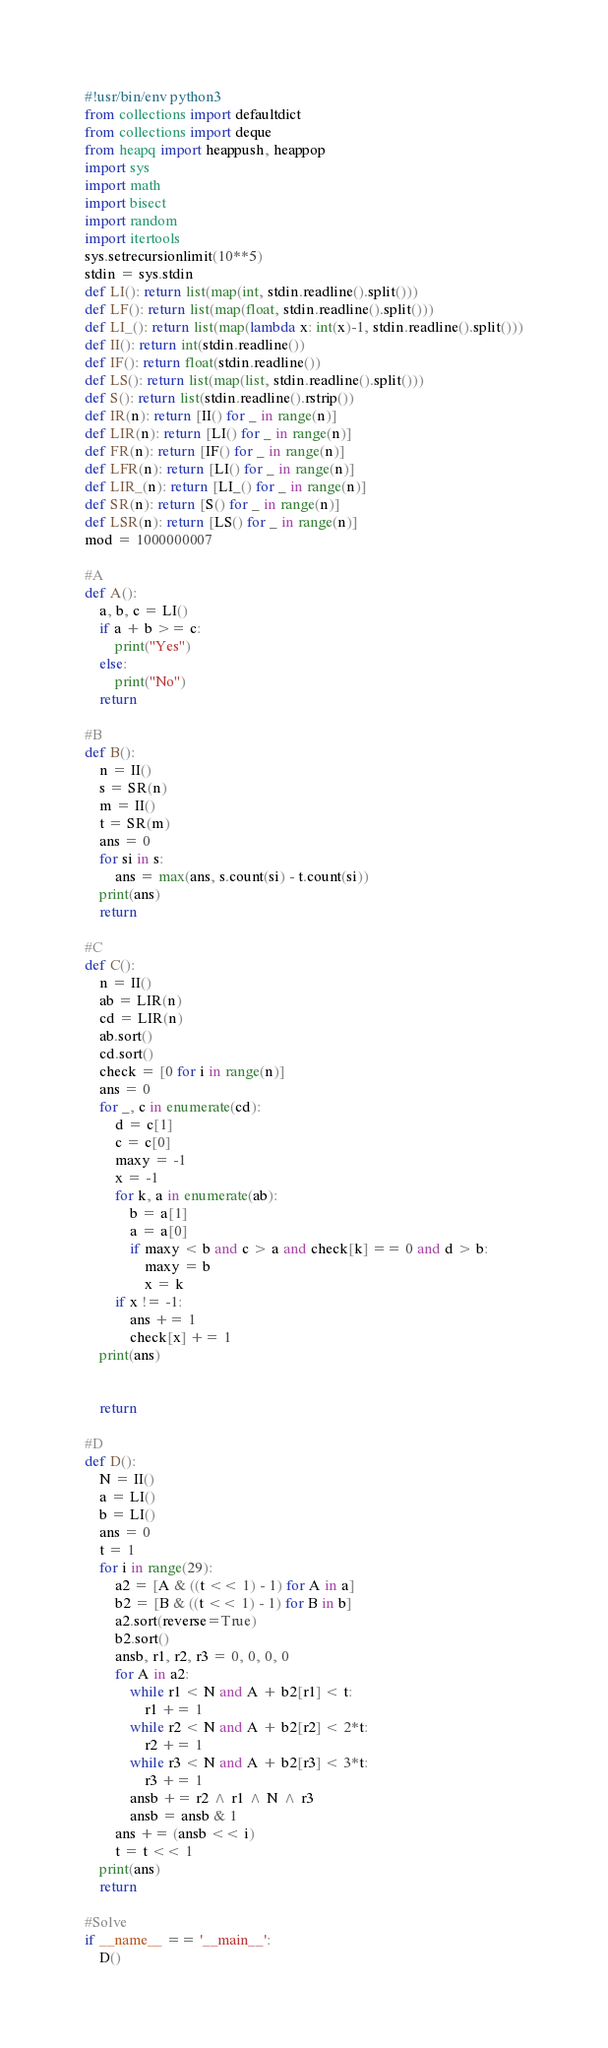<code> <loc_0><loc_0><loc_500><loc_500><_Python_>#!usr/bin/env python3
from collections import defaultdict
from collections import deque
from heapq import heappush, heappop
import sys
import math
import bisect
import random
import itertools
sys.setrecursionlimit(10**5)
stdin = sys.stdin
def LI(): return list(map(int, stdin.readline().split()))
def LF(): return list(map(float, stdin.readline().split()))
def LI_(): return list(map(lambda x: int(x)-1, stdin.readline().split()))
def II(): return int(stdin.readline())
def IF(): return float(stdin.readline())
def LS(): return list(map(list, stdin.readline().split()))
def S(): return list(stdin.readline().rstrip())
def IR(n): return [II() for _ in range(n)]
def LIR(n): return [LI() for _ in range(n)]
def FR(n): return [IF() for _ in range(n)]
def LFR(n): return [LI() for _ in range(n)]
def LIR_(n): return [LI_() for _ in range(n)]
def SR(n): return [S() for _ in range(n)]
def LSR(n): return [LS() for _ in range(n)]
mod = 1000000007

#A
def A():
    a, b, c = LI()
    if a + b >= c:
        print("Yes")
    else:
        print("No")
    return

#B
def B():
    n = II()
    s = SR(n)
    m = II()
    t = SR(m)
    ans = 0
    for si in s:
        ans = max(ans, s.count(si) - t.count(si))
    print(ans)
    return

#C
def C():
    n = II()
    ab = LIR(n)
    cd = LIR(n)
    ab.sort()
    cd.sort()
    check = [0 for i in range(n)]
    ans = 0
    for _, c in enumerate(cd):
        d = c[1]
        c = c[0]
        maxy = -1
        x = -1
        for k, a in enumerate(ab):
            b = a[1]
            a = a[0]
            if maxy < b and c > a and check[k] == 0 and d > b:
                maxy = b
                x = k
        if x != -1:
            ans += 1
            check[x] += 1
    print(ans)


    return

#D
def D():
    N = II()
    a = LI()
    b = LI()
    ans = 0
    t = 1
    for i in range(29):
        a2 = [A & ((t << 1) - 1) for A in a]
        b2 = [B & ((t << 1) - 1) for B in b]
        a2.sort(reverse=True)
        b2.sort()
        ansb, r1, r2, r3 = 0, 0, 0, 0
        for A in a2:
            while r1 < N and A + b2[r1] < t:
                r1 += 1
            while r2 < N and A + b2[r2] < 2*t:
                r2 += 1
            while r3 < N and A + b2[r3] < 3*t:
                r3 += 1
            ansb += r2 ^ r1 ^ N ^ r3
            ansb = ansb & 1
        ans += (ansb << i)
        t = t << 1
    print(ans)
    return

#Solve
if __name__ == '__main__':
    D()
</code> 